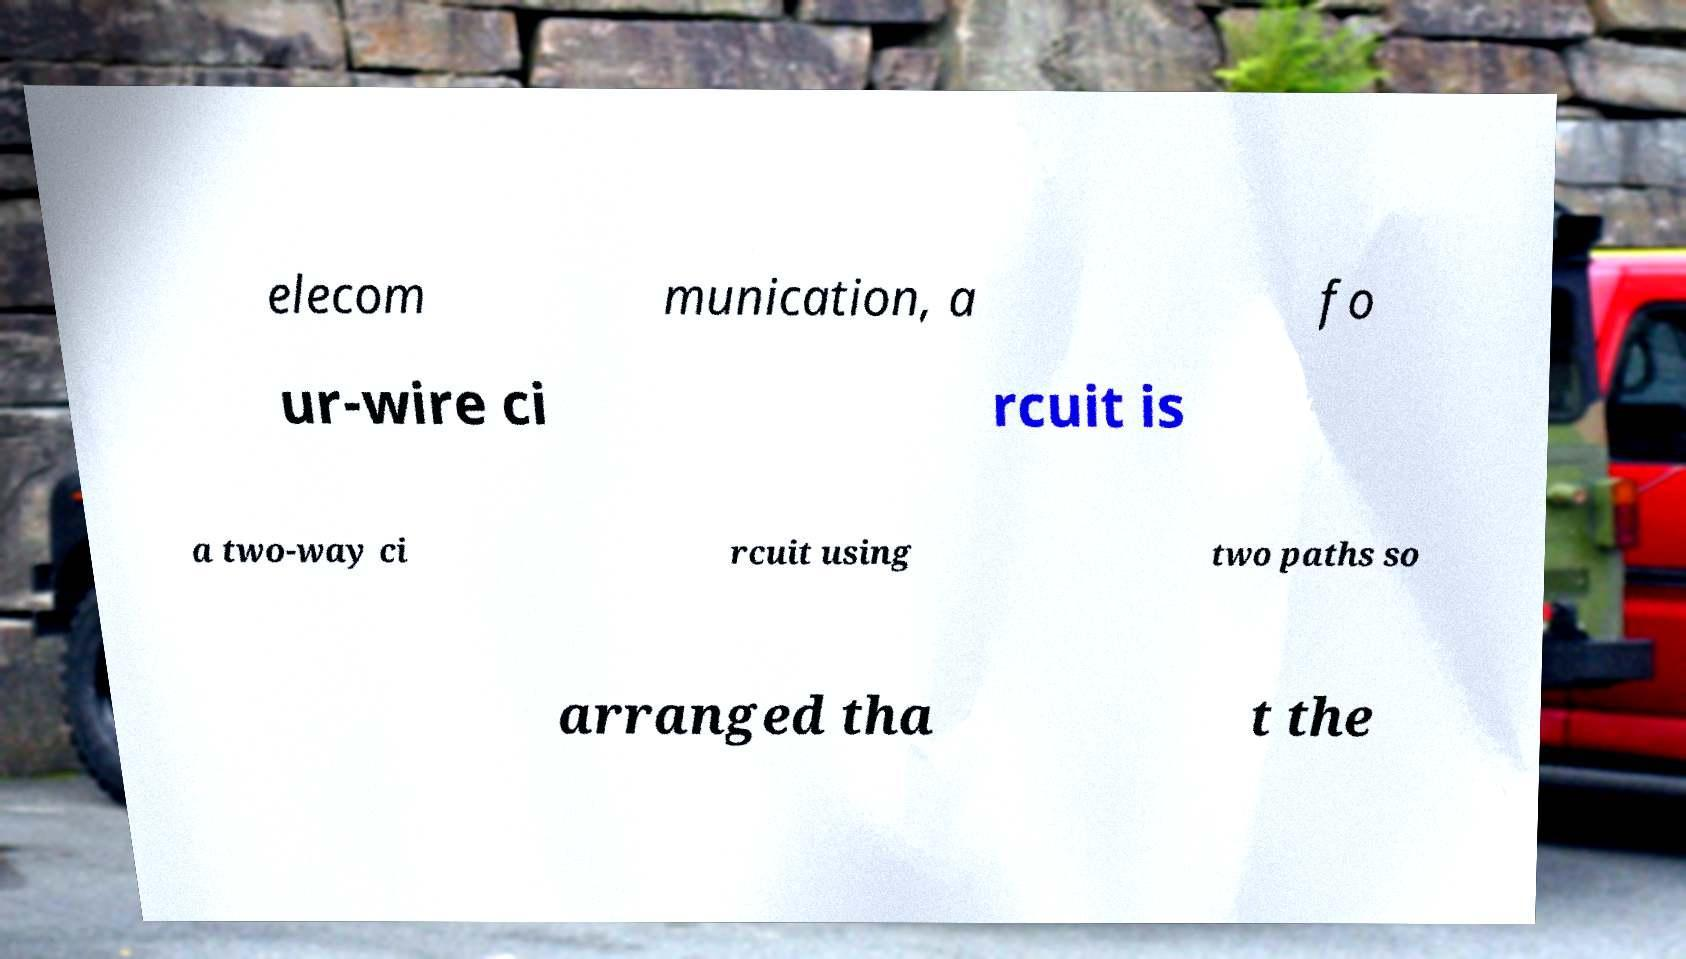Can you read and provide the text displayed in the image?This photo seems to have some interesting text. Can you extract and type it out for me? elecom munication, a fo ur-wire ci rcuit is a two-way ci rcuit using two paths so arranged tha t the 